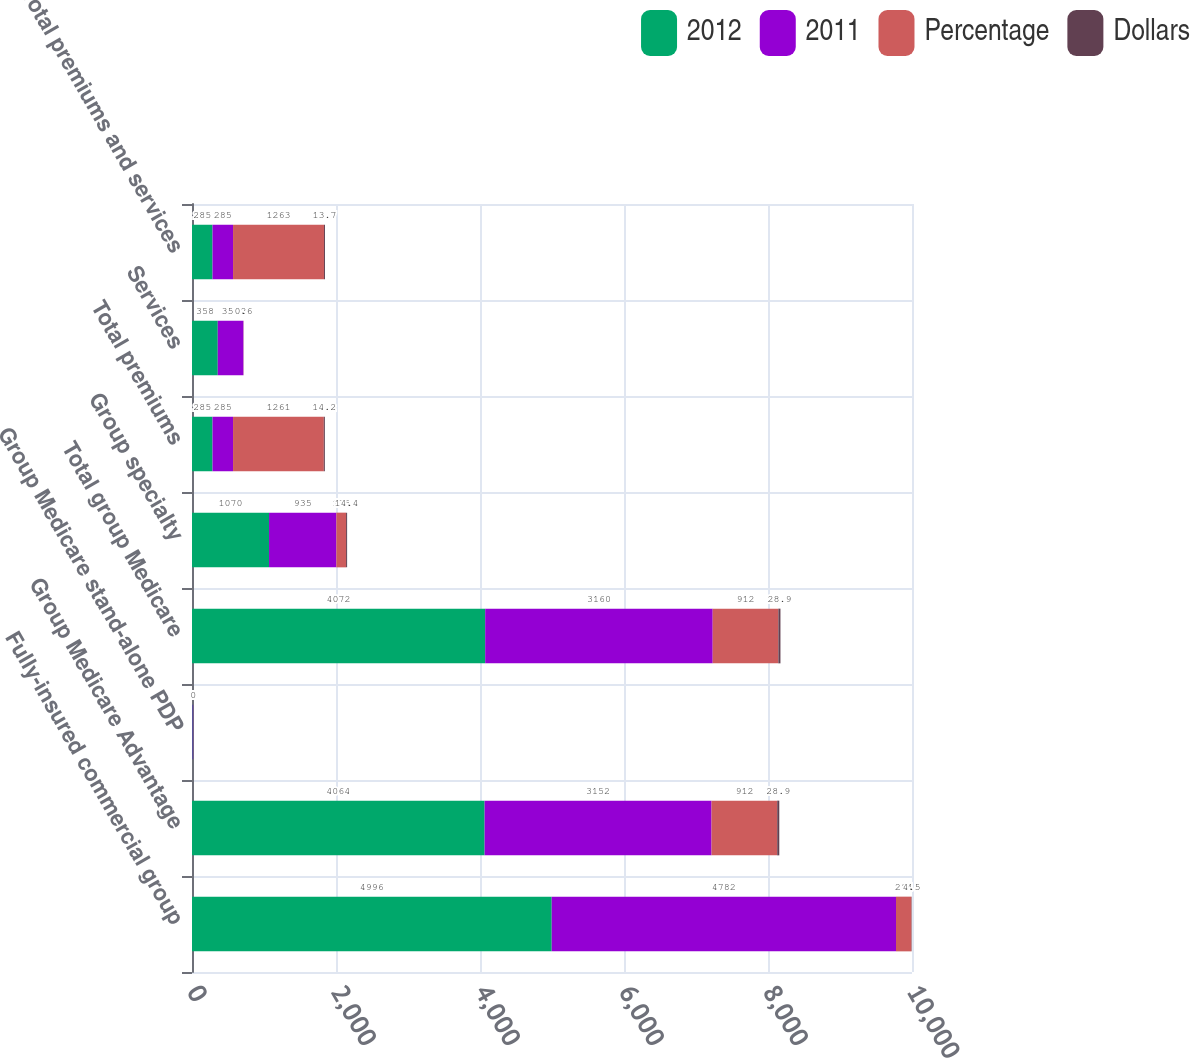Convert chart. <chart><loc_0><loc_0><loc_500><loc_500><stacked_bar_chart><ecel><fcel>Fully-insured commercial group<fcel>Group Medicare Advantage<fcel>Group Medicare stand-alone PDP<fcel>Total group Medicare<fcel>Group specialty<fcel>Total premiums<fcel>Services<fcel>Total premiums and services<nl><fcel>2012<fcel>4996<fcel>4064<fcel>8<fcel>4072<fcel>1070<fcel>285<fcel>358<fcel>285<nl><fcel>2011<fcel>4782<fcel>3152<fcel>8<fcel>3160<fcel>935<fcel>285<fcel>356<fcel>285<nl><fcel>Percentage<fcel>214<fcel>912<fcel>0<fcel>912<fcel>135<fcel>1261<fcel>2<fcel>1263<nl><fcel>Dollars<fcel>4.5<fcel>28.9<fcel>0<fcel>28.9<fcel>14.4<fcel>14.2<fcel>0.6<fcel>13.7<nl></chart> 